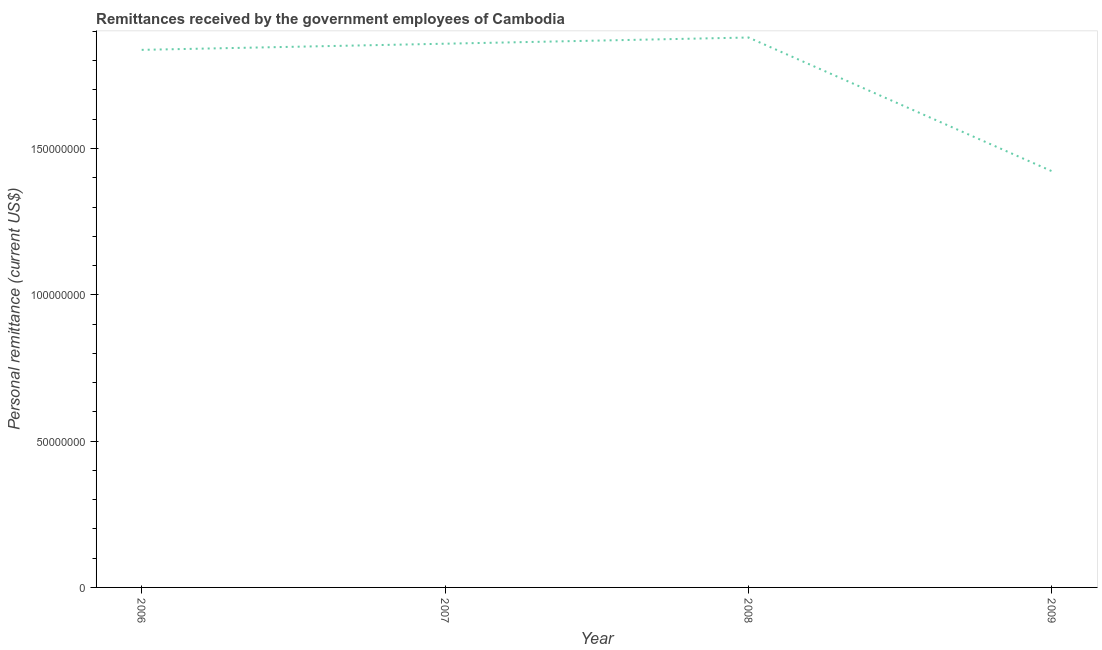What is the personal remittances in 2006?
Offer a very short reply. 1.84e+08. Across all years, what is the maximum personal remittances?
Offer a very short reply. 1.88e+08. Across all years, what is the minimum personal remittances?
Your answer should be very brief. 1.42e+08. What is the sum of the personal remittances?
Provide a succinct answer. 7.00e+08. What is the difference between the personal remittances in 2006 and 2008?
Keep it short and to the point. -4.22e+06. What is the average personal remittances per year?
Your response must be concise. 1.75e+08. What is the median personal remittances?
Keep it short and to the point. 1.85e+08. In how many years, is the personal remittances greater than 30000000 US$?
Provide a short and direct response. 4. Do a majority of the years between 2009 and 2008 (inclusive) have personal remittances greater than 20000000 US$?
Offer a very short reply. No. What is the ratio of the personal remittances in 2006 to that in 2008?
Make the answer very short. 0.98. Is the personal remittances in 2006 less than that in 2009?
Provide a succinct answer. No. Is the difference between the personal remittances in 2007 and 2009 greater than the difference between any two years?
Make the answer very short. No. What is the difference between the highest and the second highest personal remittances?
Keep it short and to the point. 2.12e+06. What is the difference between the highest and the lowest personal remittances?
Provide a succinct answer. 4.57e+07. Does the personal remittances monotonically increase over the years?
Offer a terse response. No. What is the difference between two consecutive major ticks on the Y-axis?
Your response must be concise. 5.00e+07. Are the values on the major ticks of Y-axis written in scientific E-notation?
Ensure brevity in your answer.  No. Does the graph contain grids?
Make the answer very short. No. What is the title of the graph?
Make the answer very short. Remittances received by the government employees of Cambodia. What is the label or title of the X-axis?
Ensure brevity in your answer.  Year. What is the label or title of the Y-axis?
Make the answer very short. Personal remittance (current US$). What is the Personal remittance (current US$) in 2006?
Your answer should be very brief. 1.84e+08. What is the Personal remittance (current US$) in 2007?
Offer a terse response. 1.86e+08. What is the Personal remittance (current US$) of 2008?
Ensure brevity in your answer.  1.88e+08. What is the Personal remittance (current US$) of 2009?
Your answer should be compact. 1.42e+08. What is the difference between the Personal remittance (current US$) in 2006 and 2007?
Provide a short and direct response. -2.10e+06. What is the difference between the Personal remittance (current US$) in 2006 and 2008?
Make the answer very short. -4.22e+06. What is the difference between the Personal remittance (current US$) in 2006 and 2009?
Make the answer very short. 4.15e+07. What is the difference between the Personal remittance (current US$) in 2007 and 2008?
Your answer should be very brief. -2.12e+06. What is the difference between the Personal remittance (current US$) in 2007 and 2009?
Your answer should be compact. 4.36e+07. What is the difference between the Personal remittance (current US$) in 2008 and 2009?
Ensure brevity in your answer.  4.57e+07. What is the ratio of the Personal remittance (current US$) in 2006 to that in 2007?
Offer a very short reply. 0.99. What is the ratio of the Personal remittance (current US$) in 2006 to that in 2008?
Offer a very short reply. 0.98. What is the ratio of the Personal remittance (current US$) in 2006 to that in 2009?
Ensure brevity in your answer.  1.29. What is the ratio of the Personal remittance (current US$) in 2007 to that in 2008?
Provide a succinct answer. 0.99. What is the ratio of the Personal remittance (current US$) in 2007 to that in 2009?
Ensure brevity in your answer.  1.31. What is the ratio of the Personal remittance (current US$) in 2008 to that in 2009?
Your answer should be compact. 1.32. 